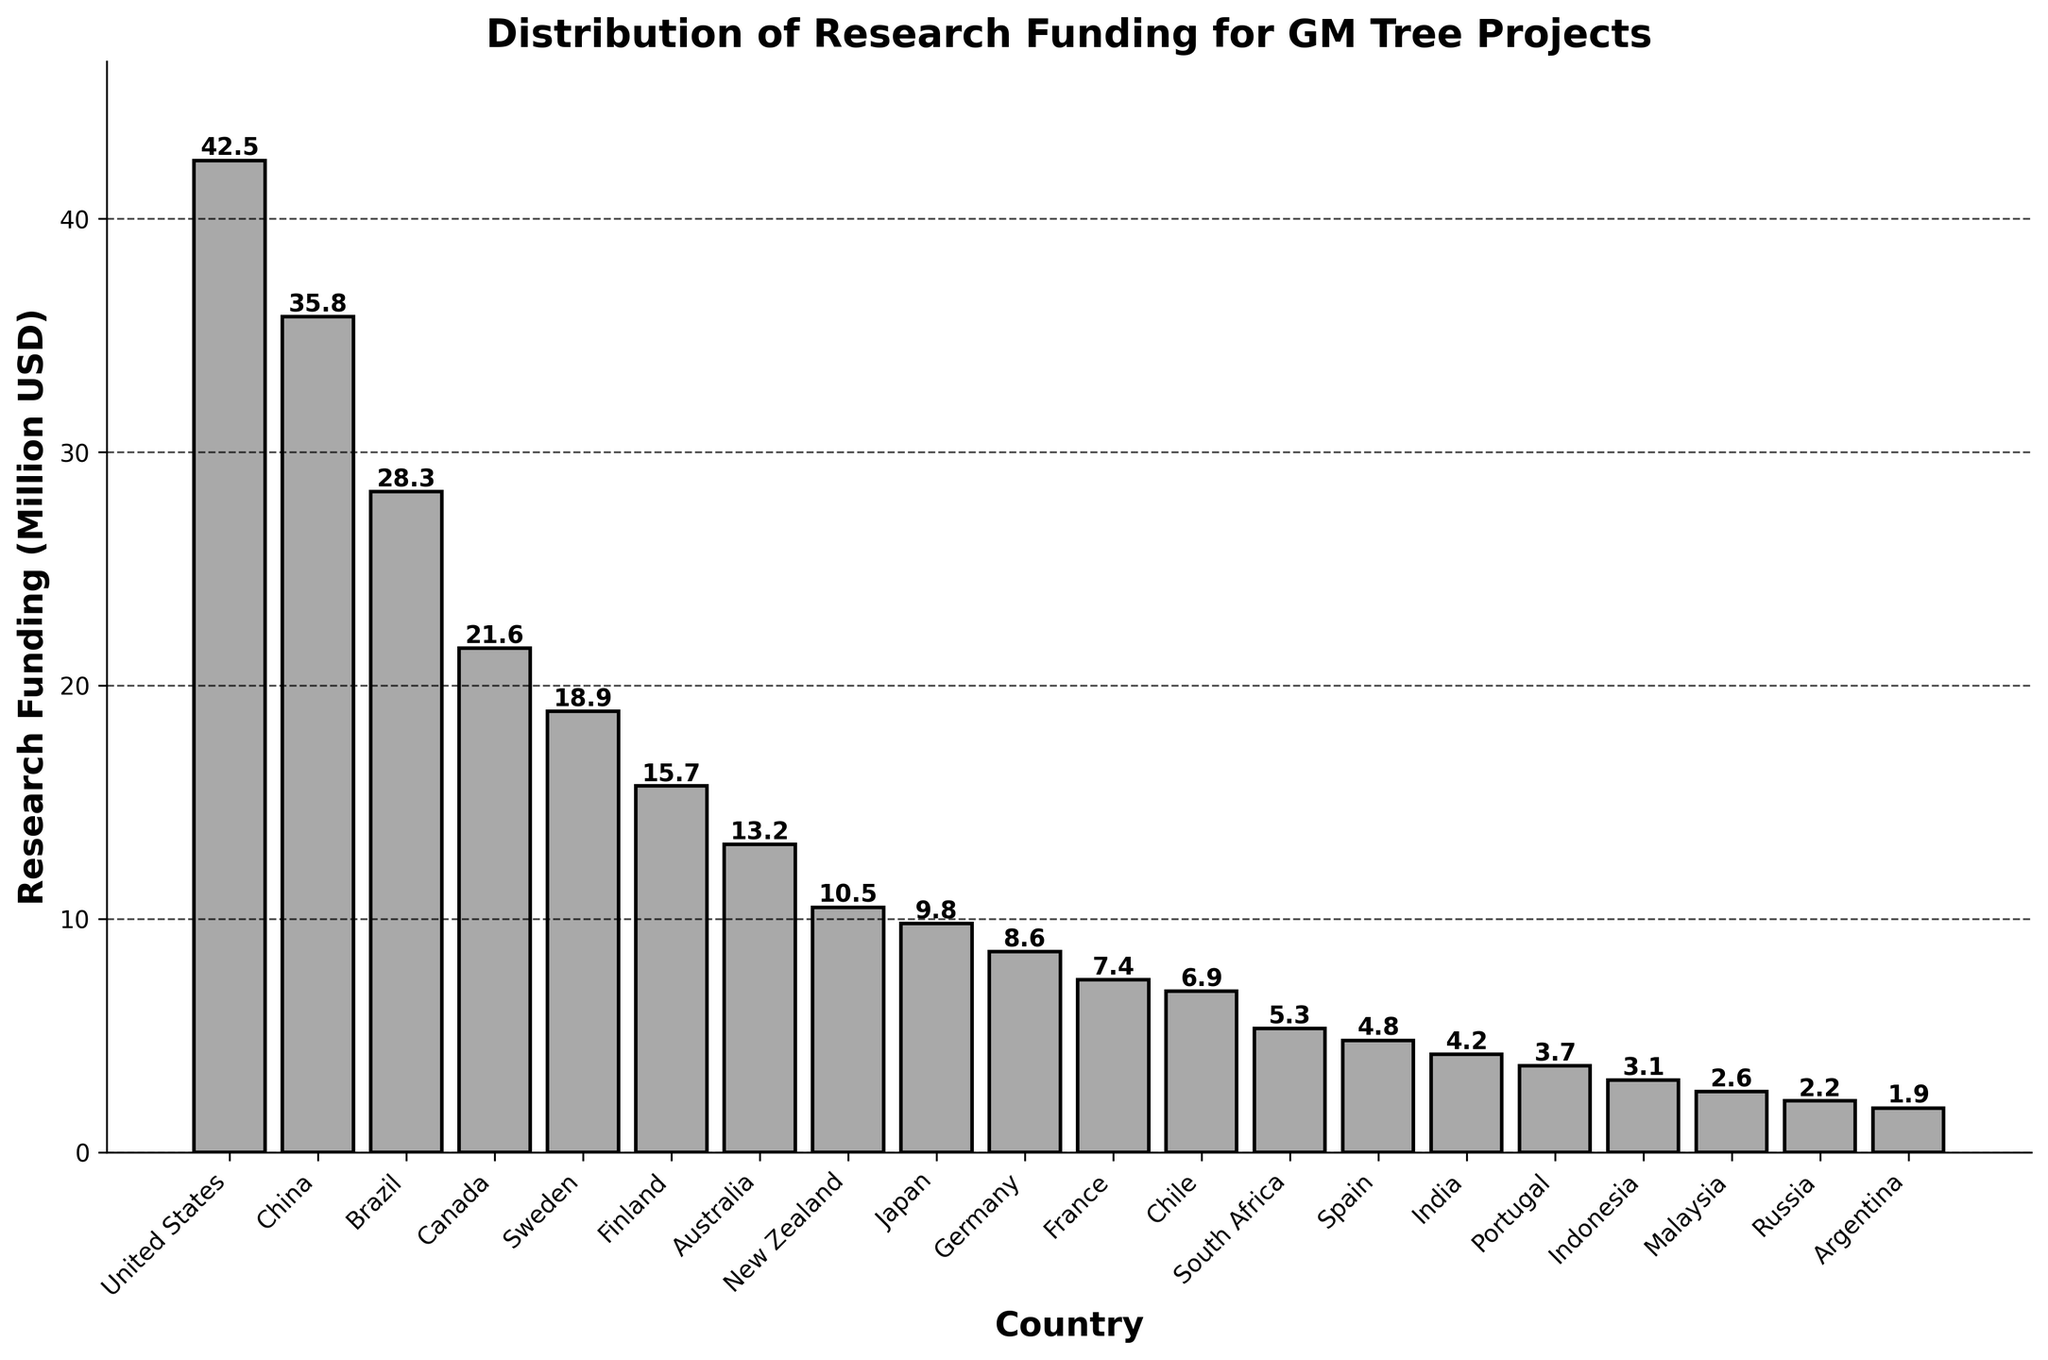What is the total research funding for the top three countries? First, identify the top three countries based on the height of the bars. They are the United States, China, and Brazil. Sum their funding values: 42.5 + 35.8 + 28.3. This gives a total of 106.6 million USD.
Answer: 106.6 million USD Which country has the highest research funding for GM tree projects? The bar for the United States is the tallest among all the countries, indicating it has the highest funding value. The figure at the top of its bar also confirms this as 42.5 million USD.
Answer: United States How much more funding does Canada have compared to France? Locate the bars for Canada and France. Canada's bar represents 21.6 million USD and France's bar represents 7.4 million USD. Calculate the difference: 21.6 - 7.4, which equals 14.2 million USD.
Answer: 14.2 million USD What is the average research funding for the countries listed in the figure? Sum the funding values for all 20 countries and divide by 20. The total funding is 267.3 (calculated by summing each country's funding). The average is then 267.3 / 20 = 13.365 million USD.
Answer: 13.365 million USD Which countries have research funding less than 5 million USD? Look at the bars and identify those below the 5 million USD mark. The bars for South Africa, Spain, India, Portugal, Indonesia, Malaysia, and Argentina are below this threshold.
Answer: South Africa, Spain, India, Portugal, Indonesia, Malaysia, Argentina Which country has just slightly more funding than Japan? Identify the bar for Japan (9.8 million USD). The next bar with a higher value is New Zealand, which has 10.5 million USD.
Answer: New Zealand What's the difference in research funding between the country with the highest and the lowest funding? The United States has the highest funding at 42.5 million USD. Argentina has the lowest funding at 1.9 million USD. Calculate the difference: 42.5 - 1.9, which equals 40.6 million USD.
Answer: 40.6 million USD How does the funding for Brazil compare to the combined funding for Sweden and Finland? Brazil has 28.3 million USD. Sweden and Finland's combined funding is 18.9 + 15.7 = 34.6 million USD. Brazil's funding is less than their combined funding.
Answer: Brazil's funding is less What is the median research funding value for the countries listed? Sort the funding values and find the middle one. The sorted values are (1.9, 2.2, 2.6, 3.1, 3.7, 4.2, 4.8, 5.3, 6.9, 7.4, 8.6, 9.8, 10.5, 13.2, 15.7, 18.9, 21.6, 28.3, 35.8, 42.5). With 20 values, the median is the average of the 10th and 11th values: (7.4 + 8.6) / 2 = 8
Answer: 8 million USD What is the range of research funding values across all countries? The range is the difference between the maximum funding value and the minimum funding value. The maximum is 42.5 million USD (United States) and the minimum is 1.9 million USD (Argentina). The range is 42.5 - 1.9 = 40.6 million USD.
Answer: 40.6 million USD 